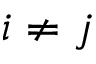<formula> <loc_0><loc_0><loc_500><loc_500>i \neq j</formula> 